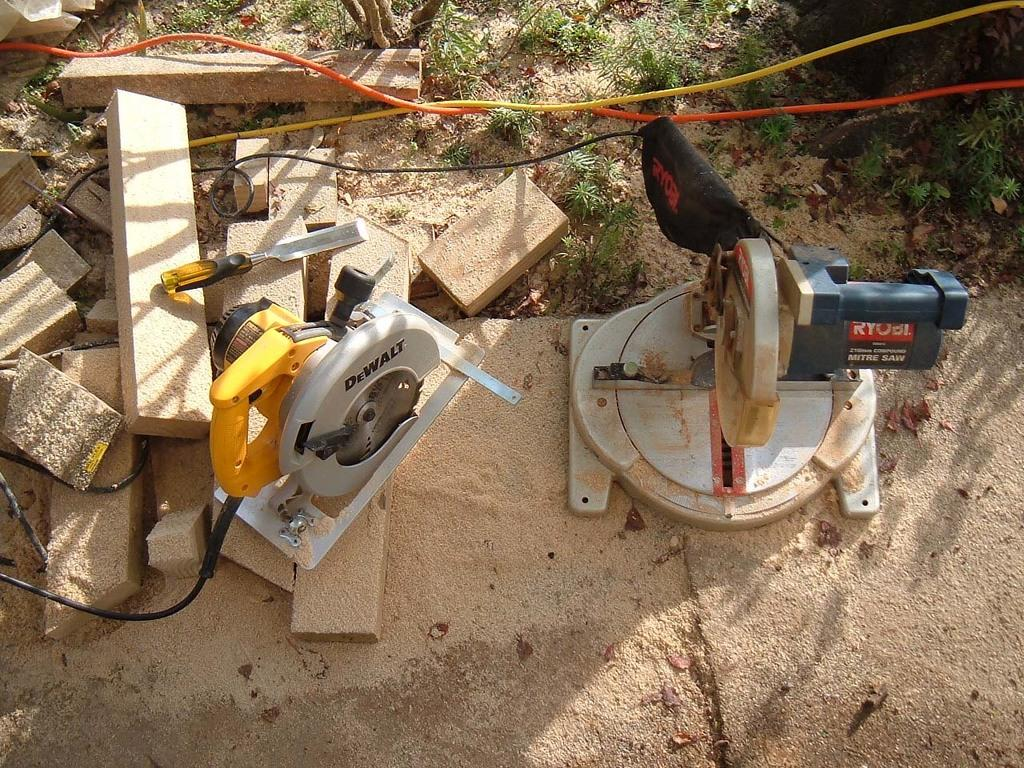What is the main subject of the image? The main subject of the image is wood cutter machines. What else can be seen in the image besides the wood cutter machines? There are wooden sticks and wires present in the image. What type of vegetation is visible at the top of the image? Grass is visible at the top of the image. What is visible in the background of the image? The ground is visible in the background of the image. What statement does the volleyball make in the image? There is no volleyball present in the image, so it cannot make any statements. Who is the achiever in the image? There is no person or achiever mentioned in the image; it primarily features wood cutter machines and related objects. 